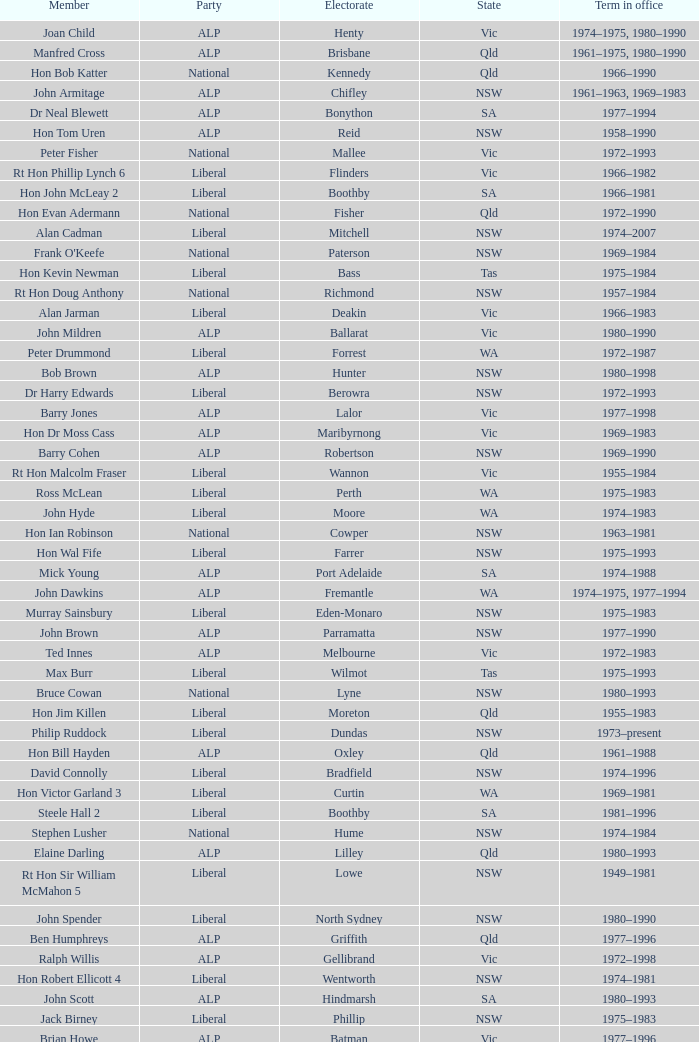To what party does Ralph Jacobi belong? ALP. 